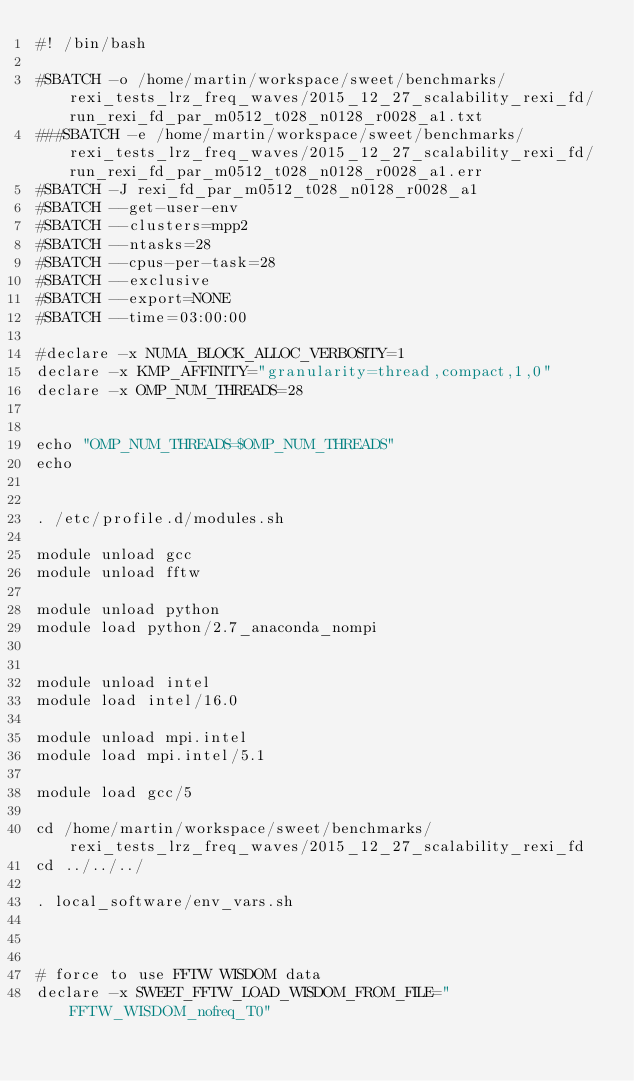<code> <loc_0><loc_0><loc_500><loc_500><_Bash_>#! /bin/bash

#SBATCH -o /home/martin/workspace/sweet/benchmarks/rexi_tests_lrz_freq_waves/2015_12_27_scalability_rexi_fd/run_rexi_fd_par_m0512_t028_n0128_r0028_a1.txt
###SBATCH -e /home/martin/workspace/sweet/benchmarks/rexi_tests_lrz_freq_waves/2015_12_27_scalability_rexi_fd/run_rexi_fd_par_m0512_t028_n0128_r0028_a1.err
#SBATCH -J rexi_fd_par_m0512_t028_n0128_r0028_a1
#SBATCH --get-user-env
#SBATCH --clusters=mpp2
#SBATCH --ntasks=28
#SBATCH --cpus-per-task=28
#SBATCH --exclusive
#SBATCH --export=NONE
#SBATCH --time=03:00:00

#declare -x NUMA_BLOCK_ALLOC_VERBOSITY=1
declare -x KMP_AFFINITY="granularity=thread,compact,1,0"
declare -x OMP_NUM_THREADS=28


echo "OMP_NUM_THREADS=$OMP_NUM_THREADS"
echo


. /etc/profile.d/modules.sh

module unload gcc
module unload fftw

module unload python
module load python/2.7_anaconda_nompi


module unload intel
module load intel/16.0

module unload mpi.intel
module load mpi.intel/5.1

module load gcc/5

cd /home/martin/workspace/sweet/benchmarks/rexi_tests_lrz_freq_waves/2015_12_27_scalability_rexi_fd
cd ../../../

. local_software/env_vars.sh



# force to use FFTW WISDOM data
declare -x SWEET_FFTW_LOAD_WISDOM_FROM_FILE="FFTW_WISDOM_nofreq_T0"
</code> 